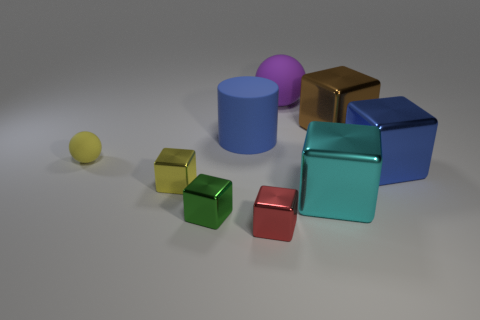Subtract all tiny yellow cubes. How many cubes are left? 5 Subtract all yellow blocks. How many blocks are left? 5 Add 1 large green matte cylinders. How many objects exist? 10 Subtract all purple blocks. Subtract all brown cylinders. How many blocks are left? 6 Add 7 red things. How many red things are left? 8 Add 4 metal blocks. How many metal blocks exist? 10 Subtract 1 blue cylinders. How many objects are left? 8 Subtract all cylinders. How many objects are left? 8 Subtract all small red cubes. Subtract all tiny things. How many objects are left? 4 